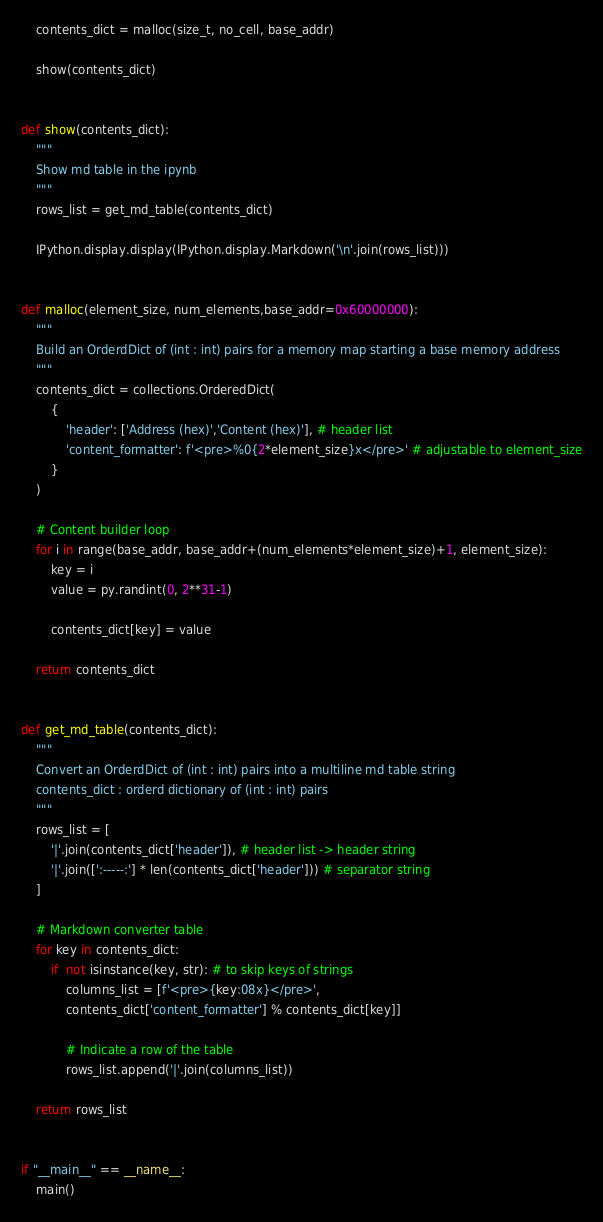<code> <loc_0><loc_0><loc_500><loc_500><_Python_>
    contents_dict = malloc(size_t, no_cell, base_addr)

    show(contents_dict)


def show(contents_dict):
    """
    Show md table in the ipynb
    """
    rows_list = get_md_table(contents_dict)

    IPython.display.display(IPython.display.Markdown('\n'.join(rows_list)))


def malloc(element_size, num_elements,base_addr=0x60000000):
    """
    Build an OrderdDict of (int : int) pairs for a memory map starting a base memory address
    """
    contents_dict = collections.OrderedDict(
        {
            'header': ['Address (hex)','Content (hex)'], # header list
            'content_formatter': f'<pre>%0{2*element_size}x</pre>' # adjustable to element_size
        }
    )

    # Content builder loop
    for i in range(base_addr, base_addr+(num_elements*element_size)+1, element_size):
        key = i
        value = py.randint(0, 2**31-1)

        contents_dict[key] = value

    return contents_dict


def get_md_table(contents_dict):
    """
    Convert an OrderdDict of (int : int) pairs into a multiline md table string
    contents_dict : orderd dictionary of (int : int) pairs
    """
    rows_list = [
        '|'.join(contents_dict['header']), # header list -> header string
        '|'.join([':-----:'] * len(contents_dict['header'])) # separator string
    ]

    # Markdown converter table
    for key in contents_dict:
        if  not isinstance(key, str): # to skip keys of strings
            columns_list = [f'<pre>{key:08x}</pre>', 
            contents_dict['content_formatter'] % contents_dict[key]]

            # Indicate a row of the table
            rows_list.append('|'.join(columns_list))

    return rows_list


if "__main__" == __name__:
    main()

</code> 